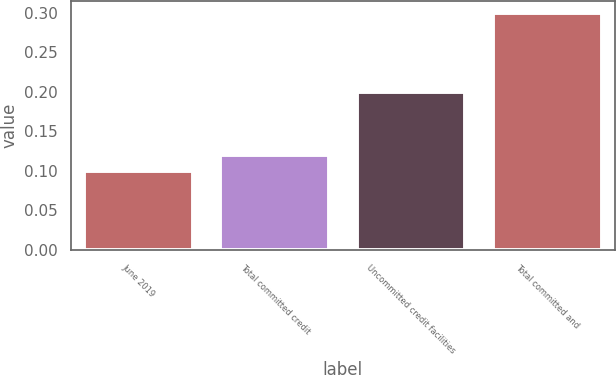<chart> <loc_0><loc_0><loc_500><loc_500><bar_chart><fcel>June 2019<fcel>Total committed credit<fcel>Uncommitted credit facilities<fcel>Total committed and<nl><fcel>0.1<fcel>0.12<fcel>0.2<fcel>0.3<nl></chart> 